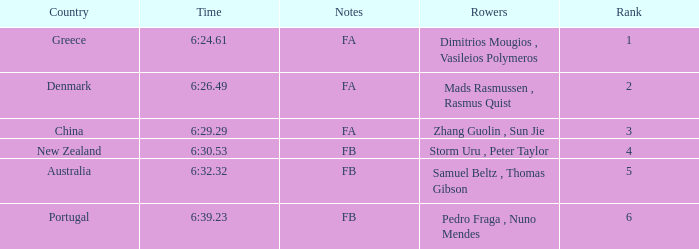Which nation has a ranking below 6, a recorded time of 6:32.32, and fb as its notes? Australia. 